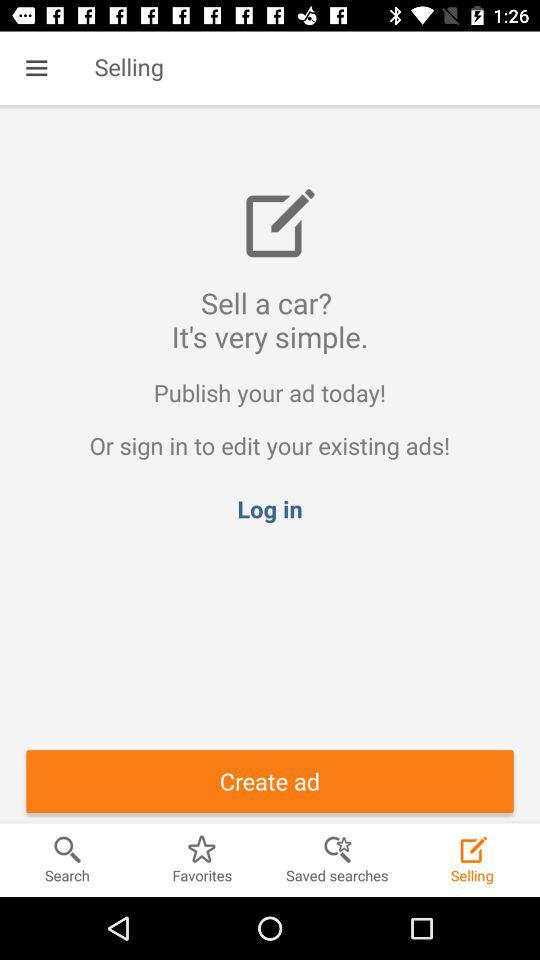Which option has been selected? The option that has been selected is "Selling". 